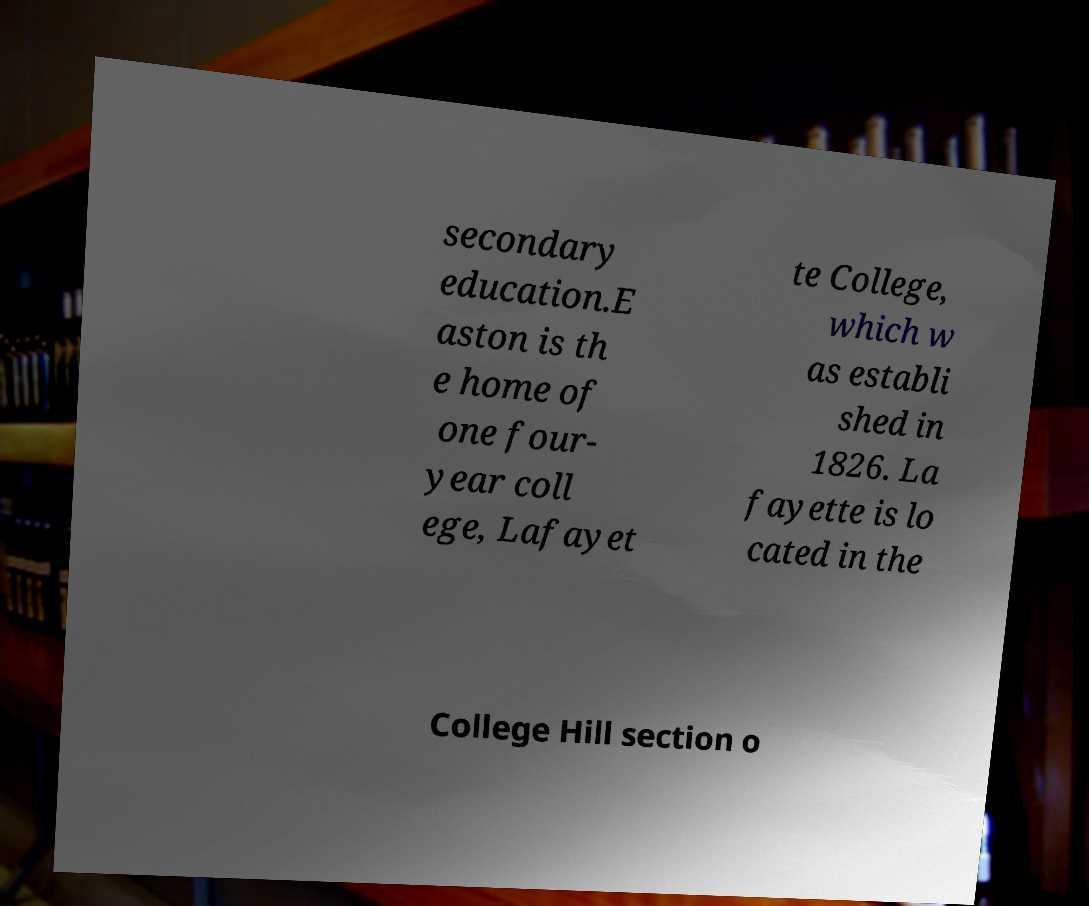Please read and relay the text visible in this image. What does it say? secondary education.E aston is th e home of one four- year coll ege, Lafayet te College, which w as establi shed in 1826. La fayette is lo cated in the College Hill section o 